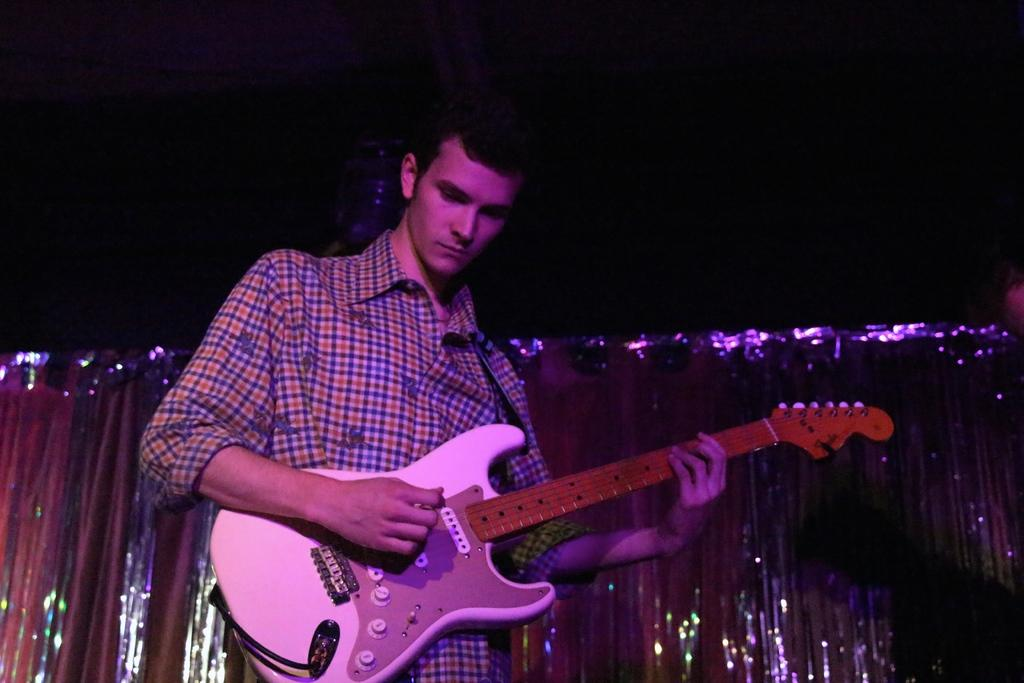What is the man in the image doing? The man is playing a guitar in the image. What can be inferred about the setting based on the sky's appearance? The sky is dark in the image, which might suggest that the scene is taking place at night or during a storm. What type of curtain can be seen hanging from the guitar in the image? There is no curtain present in the image, and the guitar is not associated with any curtains. 